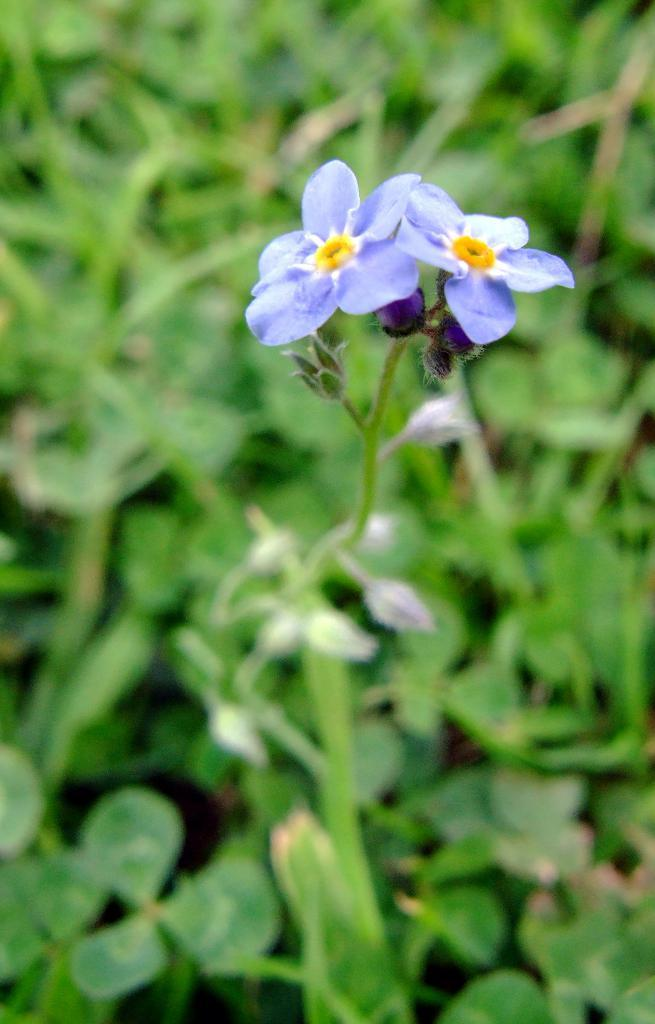What is the main subject in the center of the image? There are flowers in the center of the image. What can be seen connected to the flowers in the center of the image? There is a stem in the center of the image. How would you describe the appearance of the background in the image? The background of the image is blurred. What type of vegetation can be seen in the background of the image? There is greenery in the background of the image. What is the cause of death for the flowers in the image? There is no indication of death for the flowers in the image; they appear to be healthy and vibrant. What direction is the station located in relation to the image? There is no mention of a station in the image or the provided facts, so it is not possible to determine its direction. 